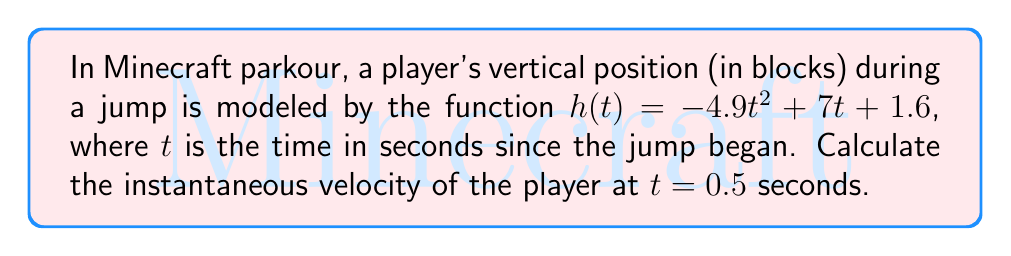Help me with this question. To find the instantaneous velocity, we need to calculate the derivative of the position function $h(t)$ and then evaluate it at $t = 0.5$ seconds.

Step 1: Find the derivative of $h(t)$
$$h(t) = -4.9t^2 + 7t + 1.6$$
$$h'(t) = -9.8t + 7$$

Step 2: Evaluate $h'(t)$ at $t = 0.5$
$$h'(0.5) = -9.8(0.5) + 7$$
$$h'(0.5) = -4.9 + 7$$
$$h'(0.5) = 2.1$$

The instantaneous velocity is 2.1 blocks per second at $t = 0.5$ seconds.

Note: In Minecraft, this positive velocity indicates the player is still moving upward at this point in the jump, which is crucial for timing your next move in parkour.
Answer: $2.1$ blocks/second 